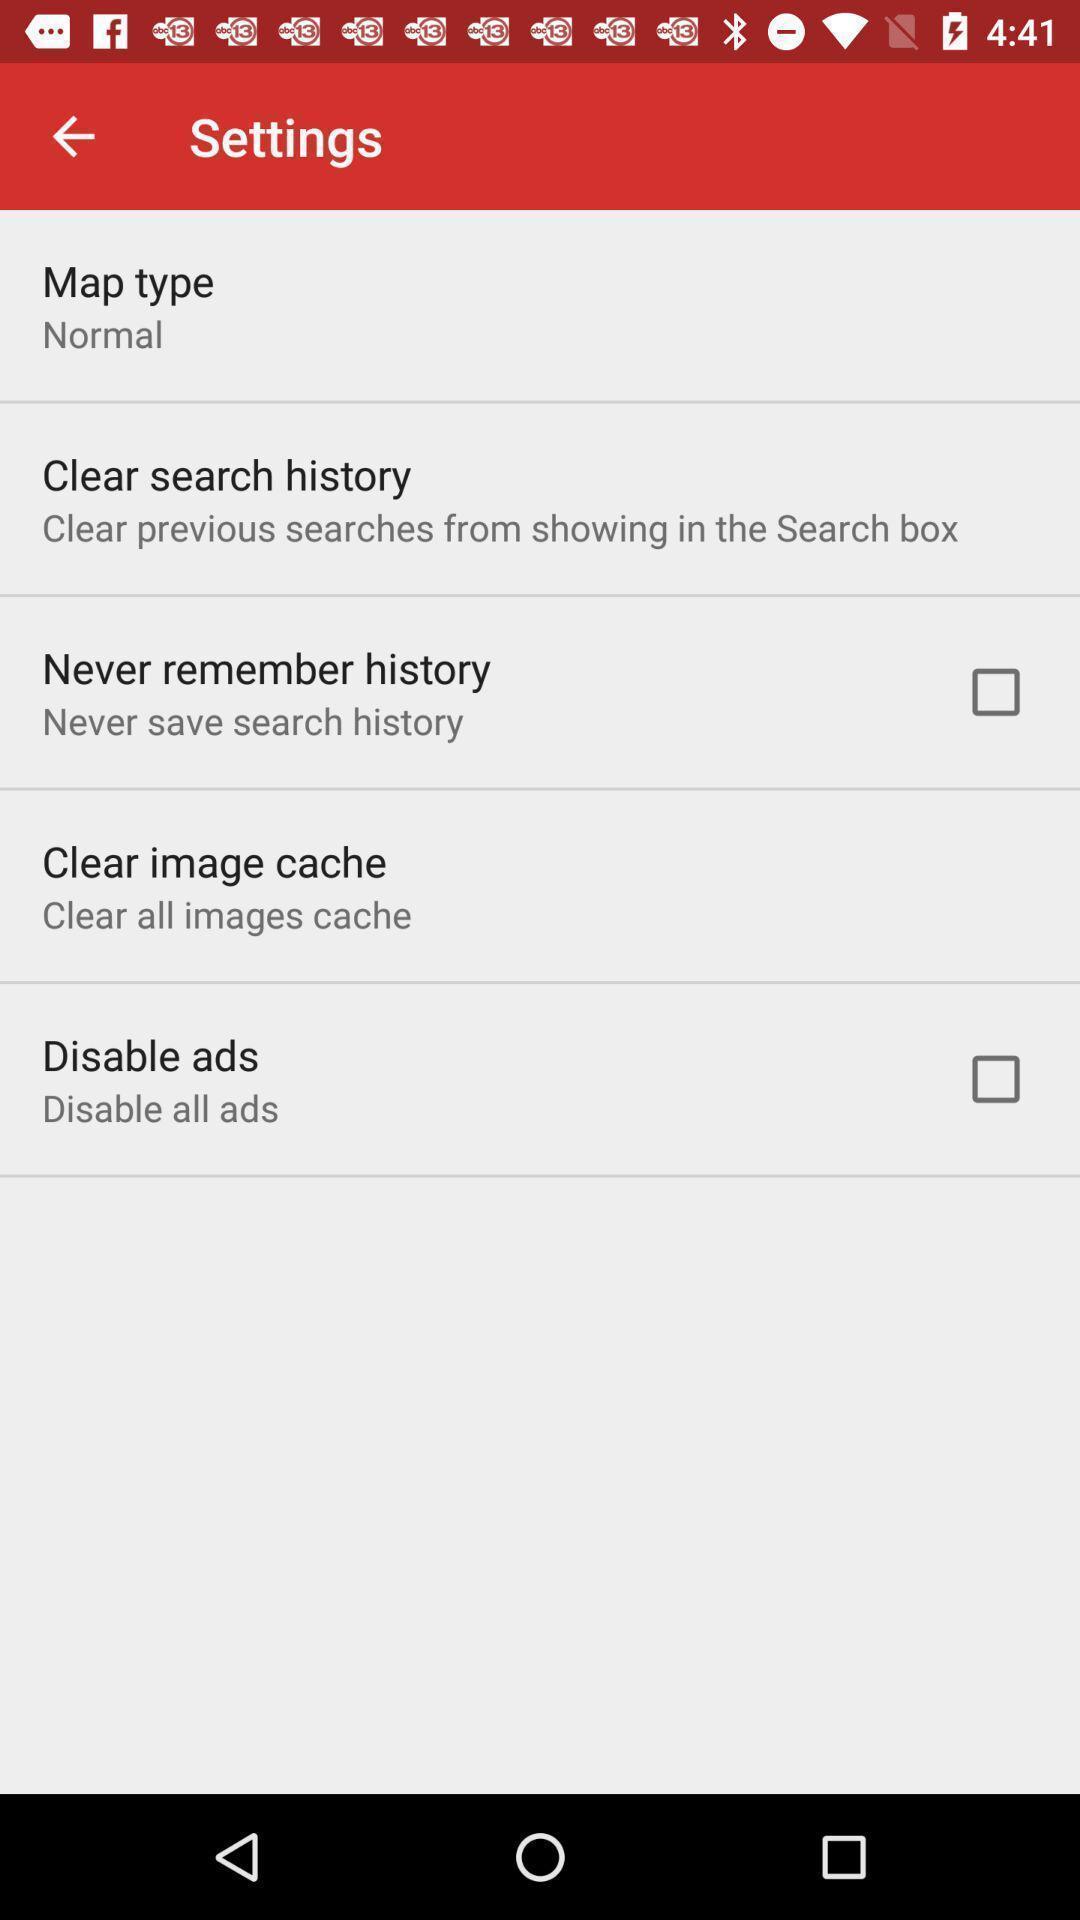Give me a summary of this screen capture. Screen displaying the settings page. 